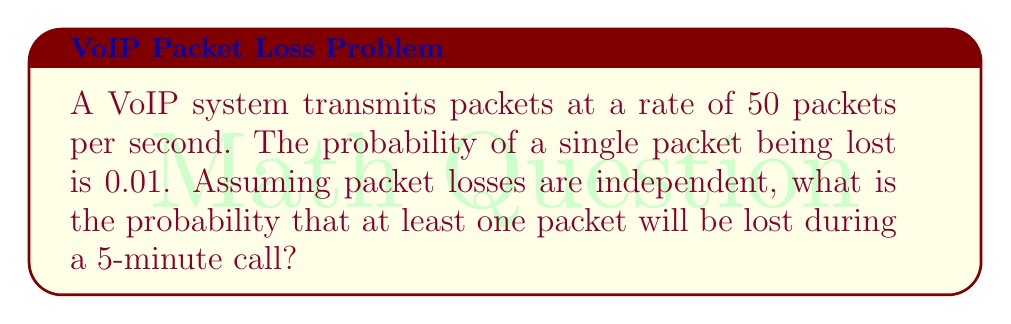Solve this math problem. Let's approach this step-by-step:

1) First, let's calculate the total number of packets transmitted during the call:
   - Duration of call = 5 minutes = 300 seconds
   - Packets per second = 50
   - Total packets = $300 \times 50 = 15000$ packets

2) The probability of a single packet being lost is 0.01, so the probability of a single packet not being lost is 0.99.

3) For no packets to be lost during the entire call, all 15000 packets must not be lost. The probability of this happening is:

   $P(\text{no loss}) = (0.99)^{15000}$

4) Therefore, the probability of at least one packet being lost is the complement of this:

   $P(\text{at least one loss}) = 1 - P(\text{no loss}) = 1 - (0.99)^{15000}$

5) Let's calculate this:

   $1 - (0.99)^{15000} = 1 - 2.9729 \times 10^{-66} \approx 0.99999999999999999999999999999999999999999999999999999999999999997$

This is extremely close to 1, indicating that packet loss is almost certain in a call of this duration.
Answer: $1 - (0.99)^{15000} \approx 0.999999999999999999999999999999999999999999999999999999999999999997$ 